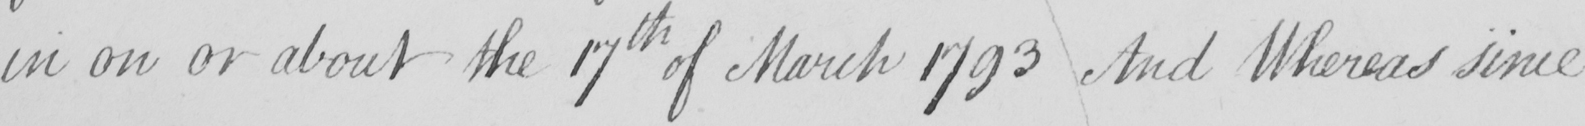Transcribe the text shown in this historical manuscript line. in on or about the 17th of March 1793 And Whereas since 